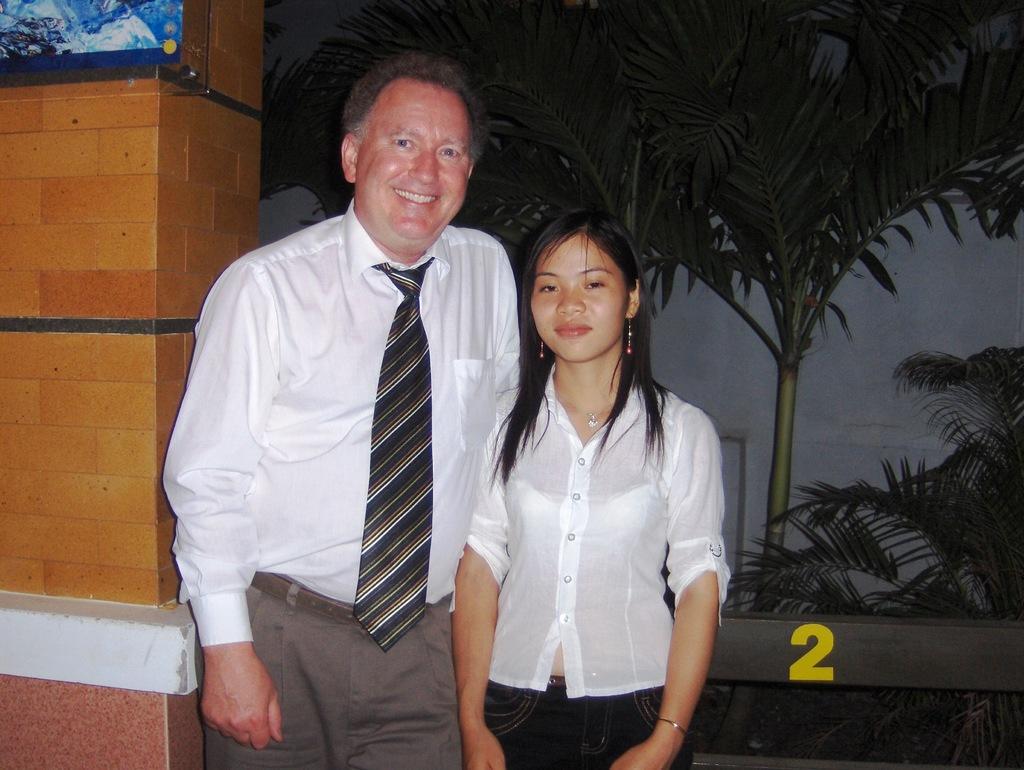In one or two sentences, can you explain what this image depicts? In front of the image there are two people standing, beside them there is a display board on the pillar, behind them there is a number on the fence, behind the fence there are plants, behind the plants there is a wall. 